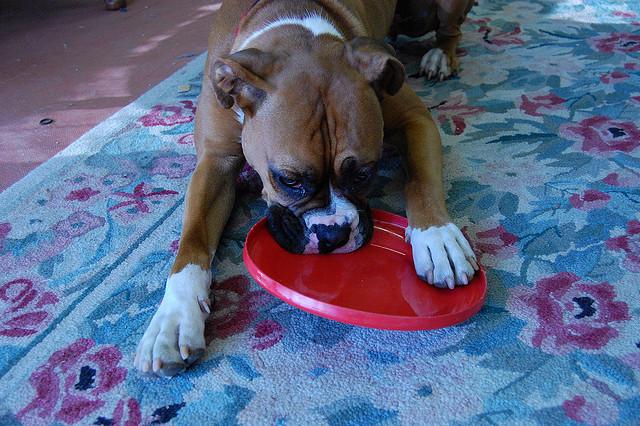What does the dog have its mouth?
Write a very short answer. Frisbee. What color is the rug?
Keep it brief. Beige pink black and green. What is the color of the freebee?
Quick response, please. Red. 